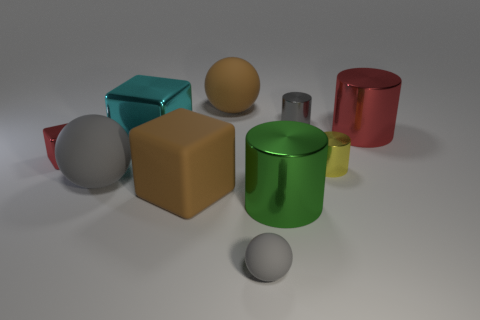There is a tiny yellow object; what shape is it?
Offer a very short reply. Cylinder. Is the color of the large metallic object on the left side of the big brown rubber ball the same as the small matte sphere?
Provide a short and direct response. No. There is a brown object that is the same shape as the tiny red object; what size is it?
Keep it short and to the point. Large. Is there anything else that is the same material as the large red cylinder?
Give a very brief answer. Yes. There is a rubber thing behind the big metallic thing on the left side of the large green object; is there a big gray sphere in front of it?
Ensure brevity in your answer.  Yes. There is a big sphere that is behind the big cyan object; what is its material?
Your answer should be very brief. Rubber. How many large objects are red shiny cylinders or brown rubber balls?
Your answer should be compact. 2. Is the size of the brown matte object that is behind the yellow cylinder the same as the yellow shiny cylinder?
Keep it short and to the point. No. What number of other objects are there of the same color as the big matte block?
Your answer should be compact. 1. What is the material of the yellow cylinder?
Give a very brief answer. Metal. 